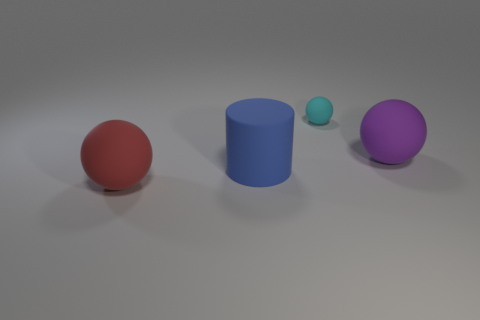Add 2 large matte cubes. How many objects exist? 6 Subtract all cylinders. How many objects are left? 3 Add 1 tiny purple cylinders. How many tiny purple cylinders exist? 1 Subtract 0 blue spheres. How many objects are left? 4 Subtract all purple matte balls. Subtract all matte balls. How many objects are left? 0 Add 2 red matte balls. How many red matte balls are left? 3 